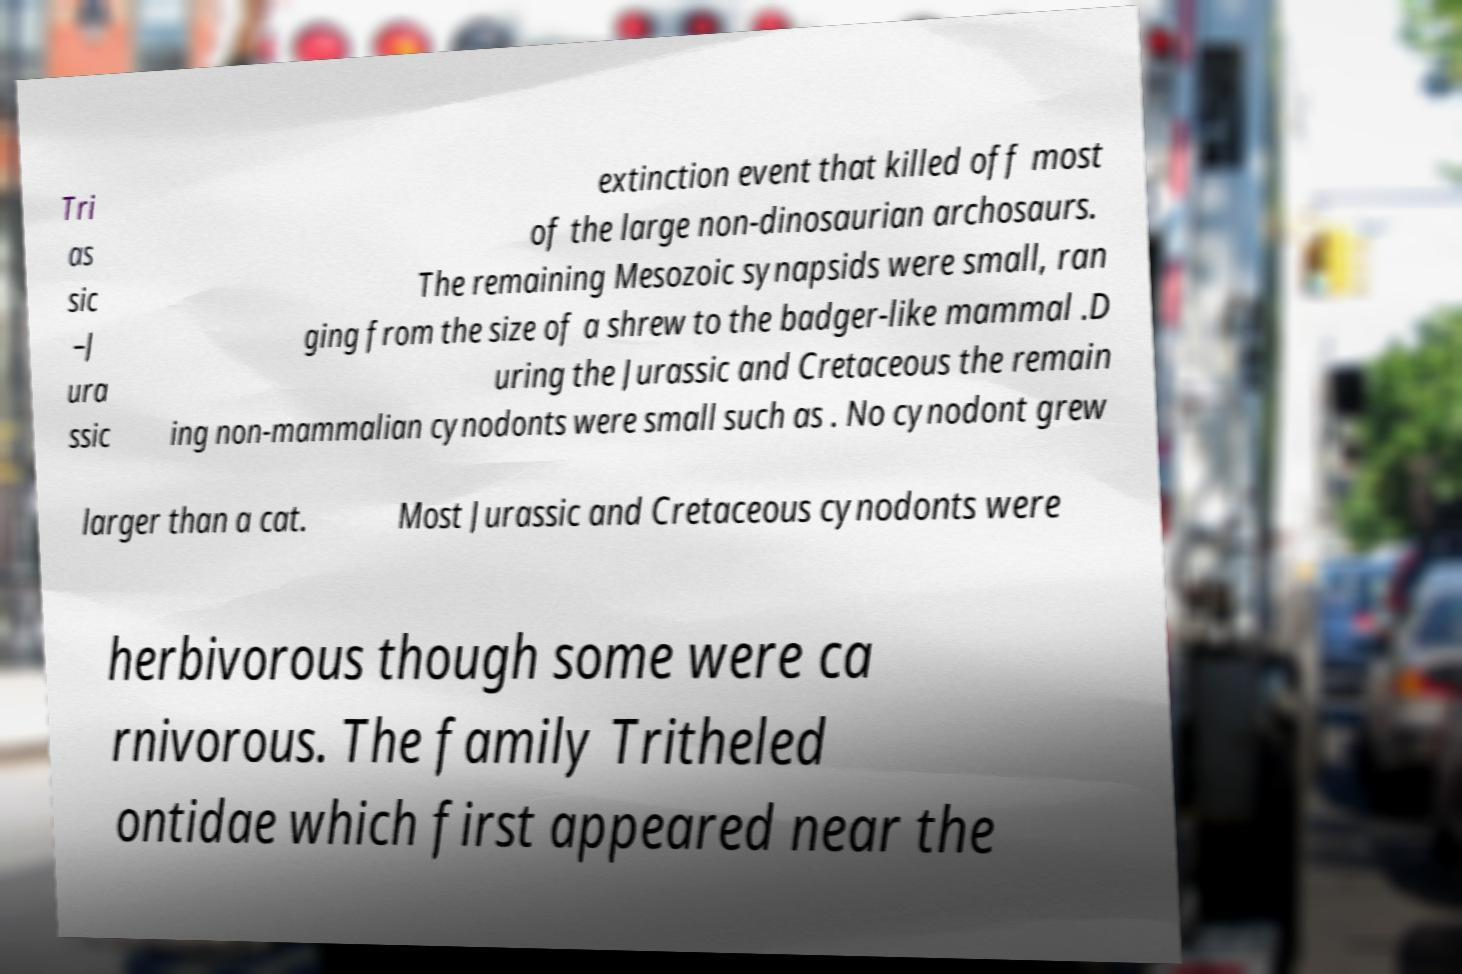Can you read and provide the text displayed in the image?This photo seems to have some interesting text. Can you extract and type it out for me? Tri as sic –J ura ssic extinction event that killed off most of the large non-dinosaurian archosaurs. The remaining Mesozoic synapsids were small, ran ging from the size of a shrew to the badger-like mammal .D uring the Jurassic and Cretaceous the remain ing non-mammalian cynodonts were small such as . No cynodont grew larger than a cat. Most Jurassic and Cretaceous cynodonts were herbivorous though some were ca rnivorous. The family Tritheled ontidae which first appeared near the 